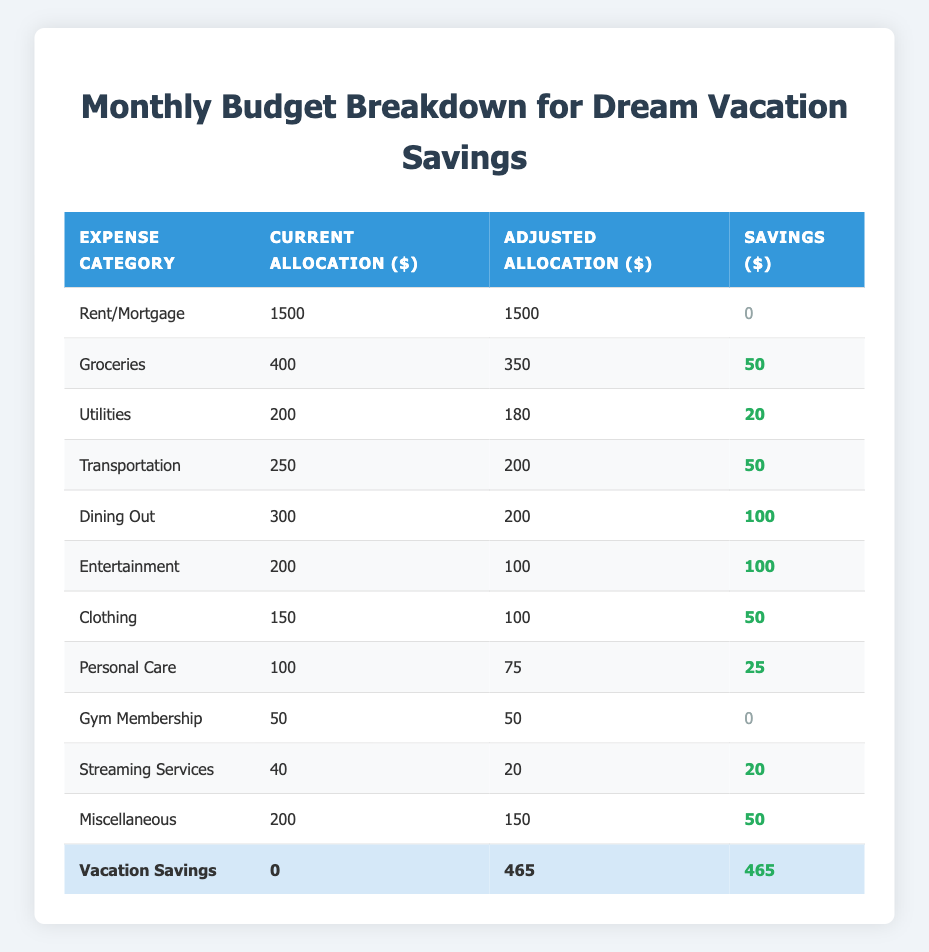What is the current allocation for groceries? The current allocation for groceries is clearly stated in the table under the "Current Allocation ($)" column next to the "Groceries" row. It shows a value of 400.
Answer: 400 How much is saved from dining out? The savings from dining out can be found in the "Savings ($)" column next to the "Dining Out" row. It indicates a savings amount of 100.
Answer: 100 What is the total savings from entertainment and dining out combined? To find the total savings from both categories, we add the savings from entertainment, which is 100, to the savings from dining out, which is 100. 100 + 100 equals 200.
Answer: 200 Is the adjusted allocation for transportation less than the adjusted allocation for groceries? The adjusted allocation for transportation is 200, while the adjusted allocation for groceries is 350. Since 200 is less than 350, the statement is true.
Answer: Yes What is the difference in savings between utilities and personal care? The savings for utilities is 20, and the savings for personal care is 25. To find the difference, we subtract the smaller savings from the larger one: 25 - 20 equals 5.
Answer: 5 What is the total current allocation for all expense categories? To find the total current allocation, we sum up all values in the "Current Allocation ($)" column: 1500 (Rent) + 400 (Groceries) + 200 (Utilities) + 250 (Transportation) + 300 (Dining Out) + 200 (Entertainment) + 150 (Clothing) + 100 (Personal Care) + 50 (Gym) + 40 (Streaming) + 200 (Miscellaneous) + 0 (Vacation Savings) equals 2890.
Answer: 2890 How much was adjusted in the clothing category? The current allocation for clothing is 150, and the adjusted allocation is 100. To find the adjustment, we subtract the adjusted amount from the current amount: 150 - 100 equals 50.
Answer: 50 What is the total amount allocated towards vacation savings? The adjusted allocation for vacation savings is 465, as indicated in the table under the "Adjusted Allocation ($)" column next to the "Vacation Savings" row.
Answer: 465 